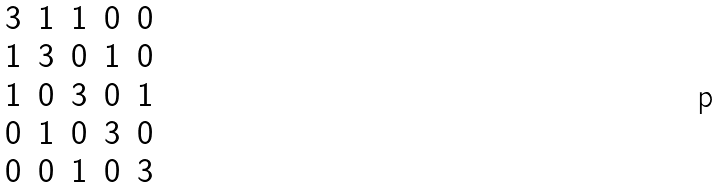<formula> <loc_0><loc_0><loc_500><loc_500>\begin{matrix} 3 & 1 & 1 & 0 & 0 \\ 1 & 3 & 0 & 1 & 0 \\ 1 & 0 & 3 & 0 & 1 \\ 0 & 1 & 0 & 3 & 0 \\ 0 & 0 & 1 & 0 & 3 \end{matrix}</formula> 